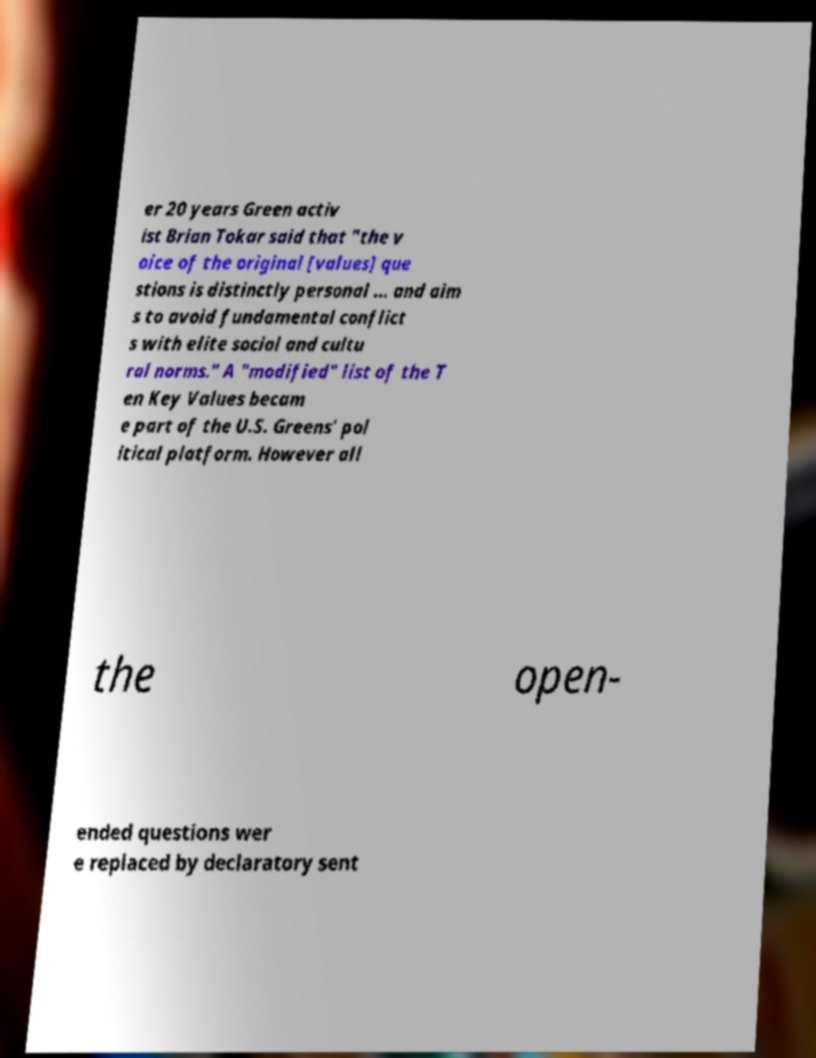What messages or text are displayed in this image? I need them in a readable, typed format. er 20 years Green activ ist Brian Tokar said that "the v oice of the original [values] que stions is distinctly personal ... and aim s to avoid fundamental conflict s with elite social and cultu ral norms." A "modified" list of the T en Key Values becam e part of the U.S. Greens' pol itical platform. However all the open- ended questions wer e replaced by declaratory sent 